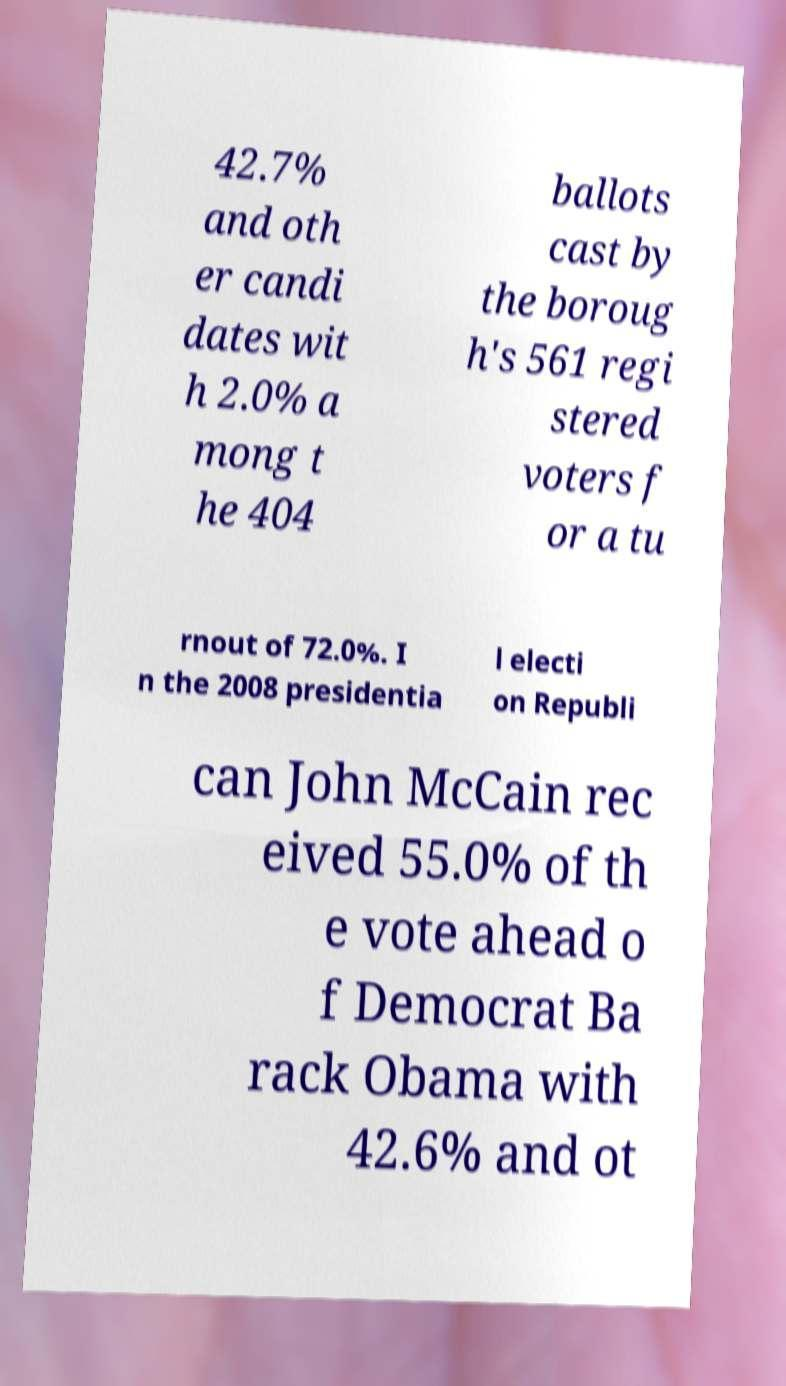Could you extract and type out the text from this image? 42.7% and oth er candi dates wit h 2.0% a mong t he 404 ballots cast by the boroug h's 561 regi stered voters f or a tu rnout of 72.0%. I n the 2008 presidentia l electi on Republi can John McCain rec eived 55.0% of th e vote ahead o f Democrat Ba rack Obama with 42.6% and ot 